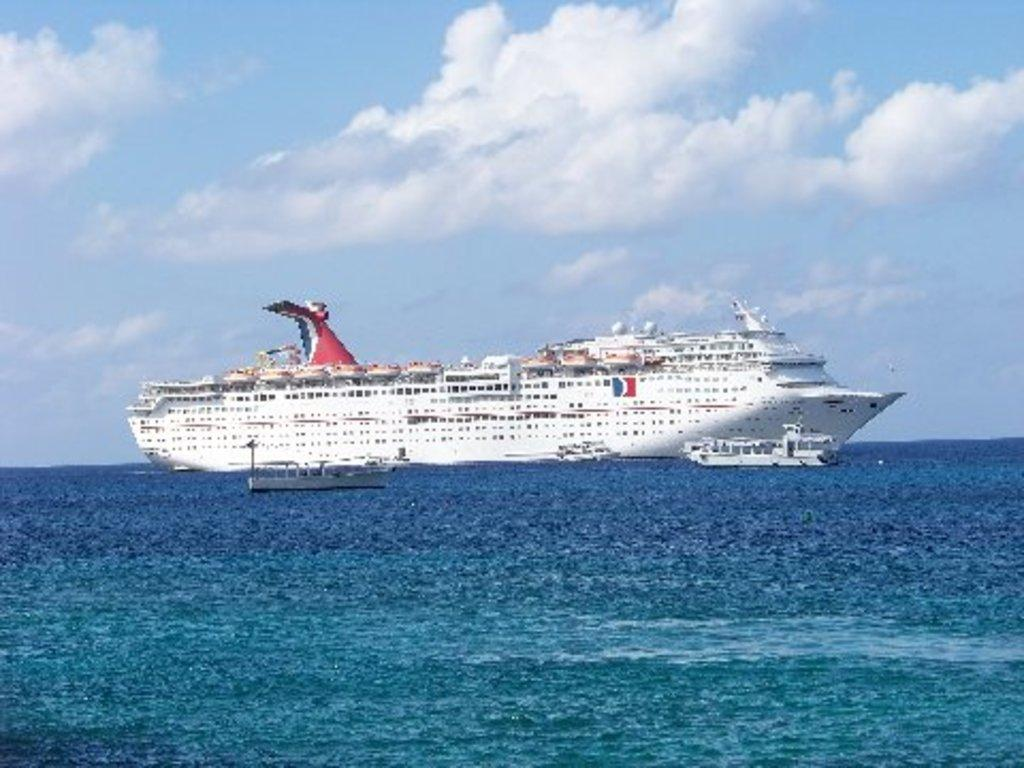What type of vehicles can be seen in the image? There are ships in the water. What part of the natural environment is visible in the image? The sky is visible in the background of the image. Where is the pin located in the image? There is no pin present in the image. What type of hole can be seen in the image? There is no hole present in the image. 